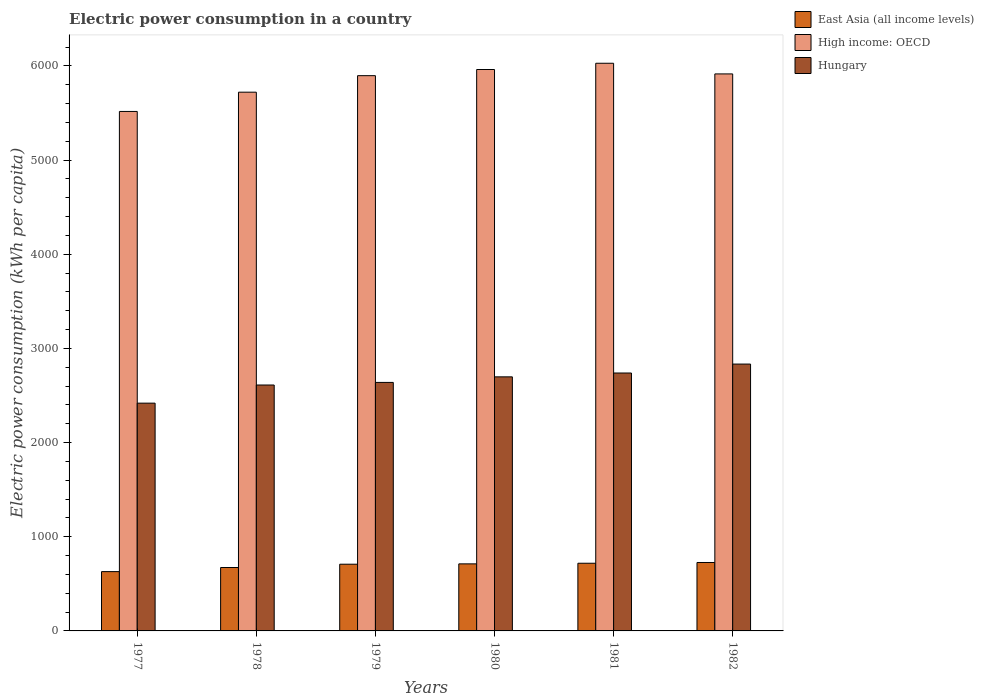How many different coloured bars are there?
Provide a succinct answer. 3. How many groups of bars are there?
Offer a very short reply. 6. Are the number of bars per tick equal to the number of legend labels?
Your answer should be very brief. Yes. How many bars are there on the 5th tick from the left?
Offer a terse response. 3. How many bars are there on the 3rd tick from the right?
Your response must be concise. 3. What is the label of the 3rd group of bars from the left?
Offer a very short reply. 1979. What is the electric power consumption in in East Asia (all income levels) in 1982?
Make the answer very short. 726.64. Across all years, what is the maximum electric power consumption in in High income: OECD?
Keep it short and to the point. 6027.52. Across all years, what is the minimum electric power consumption in in Hungary?
Make the answer very short. 2418.57. In which year was the electric power consumption in in East Asia (all income levels) maximum?
Provide a succinct answer. 1982. In which year was the electric power consumption in in East Asia (all income levels) minimum?
Offer a very short reply. 1977. What is the total electric power consumption in in Hungary in the graph?
Ensure brevity in your answer.  1.59e+04. What is the difference between the electric power consumption in in High income: OECD in 1981 and that in 1982?
Your answer should be compact. 113.2. What is the difference between the electric power consumption in in East Asia (all income levels) in 1977 and the electric power consumption in in High income: OECD in 1982?
Provide a succinct answer. -5284.6. What is the average electric power consumption in in East Asia (all income levels) per year?
Offer a very short reply. 694.78. In the year 1978, what is the difference between the electric power consumption in in East Asia (all income levels) and electric power consumption in in Hungary?
Make the answer very short. -1937.78. What is the ratio of the electric power consumption in in East Asia (all income levels) in 1978 to that in 1982?
Provide a succinct answer. 0.93. Is the electric power consumption in in East Asia (all income levels) in 1978 less than that in 1980?
Offer a very short reply. Yes. Is the difference between the electric power consumption in in East Asia (all income levels) in 1981 and 1982 greater than the difference between the electric power consumption in in Hungary in 1981 and 1982?
Your response must be concise. Yes. What is the difference between the highest and the second highest electric power consumption in in High income: OECD?
Give a very brief answer. 66.38. What is the difference between the highest and the lowest electric power consumption in in Hungary?
Provide a succinct answer. 414.92. What does the 1st bar from the left in 1982 represents?
Offer a terse response. East Asia (all income levels). What does the 3rd bar from the right in 1982 represents?
Make the answer very short. East Asia (all income levels). Are all the bars in the graph horizontal?
Provide a succinct answer. No. How many legend labels are there?
Offer a terse response. 3. What is the title of the graph?
Your answer should be very brief. Electric power consumption in a country. Does "Peru" appear as one of the legend labels in the graph?
Give a very brief answer. No. What is the label or title of the Y-axis?
Offer a very short reply. Electric power consumption (kWh per capita). What is the Electric power consumption (kWh per capita) in East Asia (all income levels) in 1977?
Your response must be concise. 629.72. What is the Electric power consumption (kWh per capita) of High income: OECD in 1977?
Provide a short and direct response. 5515.92. What is the Electric power consumption (kWh per capita) of Hungary in 1977?
Offer a terse response. 2418.57. What is the Electric power consumption (kWh per capita) of East Asia (all income levels) in 1978?
Keep it short and to the point. 673.4. What is the Electric power consumption (kWh per capita) of High income: OECD in 1978?
Make the answer very short. 5720.35. What is the Electric power consumption (kWh per capita) of Hungary in 1978?
Provide a succinct answer. 2611.18. What is the Electric power consumption (kWh per capita) of East Asia (all income levels) in 1979?
Provide a succinct answer. 708.39. What is the Electric power consumption (kWh per capita) in High income: OECD in 1979?
Your response must be concise. 5895.81. What is the Electric power consumption (kWh per capita) in Hungary in 1979?
Offer a terse response. 2638.7. What is the Electric power consumption (kWh per capita) of East Asia (all income levels) in 1980?
Keep it short and to the point. 711.96. What is the Electric power consumption (kWh per capita) of High income: OECD in 1980?
Keep it short and to the point. 5961.14. What is the Electric power consumption (kWh per capita) in Hungary in 1980?
Your response must be concise. 2697.76. What is the Electric power consumption (kWh per capita) of East Asia (all income levels) in 1981?
Keep it short and to the point. 718.57. What is the Electric power consumption (kWh per capita) in High income: OECD in 1981?
Your response must be concise. 6027.52. What is the Electric power consumption (kWh per capita) in Hungary in 1981?
Keep it short and to the point. 2738.56. What is the Electric power consumption (kWh per capita) in East Asia (all income levels) in 1982?
Your answer should be very brief. 726.64. What is the Electric power consumption (kWh per capita) in High income: OECD in 1982?
Your answer should be compact. 5914.32. What is the Electric power consumption (kWh per capita) in Hungary in 1982?
Your answer should be very brief. 2833.49. Across all years, what is the maximum Electric power consumption (kWh per capita) of East Asia (all income levels)?
Keep it short and to the point. 726.64. Across all years, what is the maximum Electric power consumption (kWh per capita) in High income: OECD?
Your answer should be very brief. 6027.52. Across all years, what is the maximum Electric power consumption (kWh per capita) in Hungary?
Ensure brevity in your answer.  2833.49. Across all years, what is the minimum Electric power consumption (kWh per capita) of East Asia (all income levels)?
Your response must be concise. 629.72. Across all years, what is the minimum Electric power consumption (kWh per capita) in High income: OECD?
Your answer should be compact. 5515.92. Across all years, what is the minimum Electric power consumption (kWh per capita) of Hungary?
Keep it short and to the point. 2418.57. What is the total Electric power consumption (kWh per capita) in East Asia (all income levels) in the graph?
Keep it short and to the point. 4168.68. What is the total Electric power consumption (kWh per capita) of High income: OECD in the graph?
Your response must be concise. 3.50e+04. What is the total Electric power consumption (kWh per capita) of Hungary in the graph?
Provide a succinct answer. 1.59e+04. What is the difference between the Electric power consumption (kWh per capita) of East Asia (all income levels) in 1977 and that in 1978?
Your answer should be very brief. -43.68. What is the difference between the Electric power consumption (kWh per capita) of High income: OECD in 1977 and that in 1978?
Keep it short and to the point. -204.43. What is the difference between the Electric power consumption (kWh per capita) of Hungary in 1977 and that in 1978?
Ensure brevity in your answer.  -192.61. What is the difference between the Electric power consumption (kWh per capita) in East Asia (all income levels) in 1977 and that in 1979?
Keep it short and to the point. -78.67. What is the difference between the Electric power consumption (kWh per capita) of High income: OECD in 1977 and that in 1979?
Your answer should be very brief. -379.89. What is the difference between the Electric power consumption (kWh per capita) of Hungary in 1977 and that in 1979?
Offer a very short reply. -220.13. What is the difference between the Electric power consumption (kWh per capita) of East Asia (all income levels) in 1977 and that in 1980?
Your answer should be very brief. -82.23. What is the difference between the Electric power consumption (kWh per capita) of High income: OECD in 1977 and that in 1980?
Offer a terse response. -445.22. What is the difference between the Electric power consumption (kWh per capita) in Hungary in 1977 and that in 1980?
Your response must be concise. -279.19. What is the difference between the Electric power consumption (kWh per capita) of East Asia (all income levels) in 1977 and that in 1981?
Ensure brevity in your answer.  -88.85. What is the difference between the Electric power consumption (kWh per capita) in High income: OECD in 1977 and that in 1981?
Offer a very short reply. -511.6. What is the difference between the Electric power consumption (kWh per capita) of Hungary in 1977 and that in 1981?
Ensure brevity in your answer.  -319.99. What is the difference between the Electric power consumption (kWh per capita) of East Asia (all income levels) in 1977 and that in 1982?
Provide a succinct answer. -96.92. What is the difference between the Electric power consumption (kWh per capita) of High income: OECD in 1977 and that in 1982?
Offer a terse response. -398.4. What is the difference between the Electric power consumption (kWh per capita) of Hungary in 1977 and that in 1982?
Make the answer very short. -414.92. What is the difference between the Electric power consumption (kWh per capita) of East Asia (all income levels) in 1978 and that in 1979?
Your answer should be compact. -34.99. What is the difference between the Electric power consumption (kWh per capita) in High income: OECD in 1978 and that in 1979?
Ensure brevity in your answer.  -175.47. What is the difference between the Electric power consumption (kWh per capita) of Hungary in 1978 and that in 1979?
Make the answer very short. -27.52. What is the difference between the Electric power consumption (kWh per capita) of East Asia (all income levels) in 1978 and that in 1980?
Your answer should be compact. -38.56. What is the difference between the Electric power consumption (kWh per capita) in High income: OECD in 1978 and that in 1980?
Give a very brief answer. -240.79. What is the difference between the Electric power consumption (kWh per capita) in Hungary in 1978 and that in 1980?
Your response must be concise. -86.58. What is the difference between the Electric power consumption (kWh per capita) in East Asia (all income levels) in 1978 and that in 1981?
Provide a succinct answer. -45.17. What is the difference between the Electric power consumption (kWh per capita) of High income: OECD in 1978 and that in 1981?
Ensure brevity in your answer.  -307.17. What is the difference between the Electric power consumption (kWh per capita) in Hungary in 1978 and that in 1981?
Keep it short and to the point. -127.38. What is the difference between the Electric power consumption (kWh per capita) of East Asia (all income levels) in 1978 and that in 1982?
Keep it short and to the point. -53.24. What is the difference between the Electric power consumption (kWh per capita) of High income: OECD in 1978 and that in 1982?
Ensure brevity in your answer.  -193.98. What is the difference between the Electric power consumption (kWh per capita) of Hungary in 1978 and that in 1982?
Your answer should be compact. -222.31. What is the difference between the Electric power consumption (kWh per capita) of East Asia (all income levels) in 1979 and that in 1980?
Ensure brevity in your answer.  -3.56. What is the difference between the Electric power consumption (kWh per capita) of High income: OECD in 1979 and that in 1980?
Give a very brief answer. -65.33. What is the difference between the Electric power consumption (kWh per capita) of Hungary in 1979 and that in 1980?
Provide a short and direct response. -59.06. What is the difference between the Electric power consumption (kWh per capita) in East Asia (all income levels) in 1979 and that in 1981?
Your response must be concise. -10.18. What is the difference between the Electric power consumption (kWh per capita) in High income: OECD in 1979 and that in 1981?
Give a very brief answer. -131.71. What is the difference between the Electric power consumption (kWh per capita) of Hungary in 1979 and that in 1981?
Make the answer very short. -99.86. What is the difference between the Electric power consumption (kWh per capita) of East Asia (all income levels) in 1979 and that in 1982?
Offer a very short reply. -18.25. What is the difference between the Electric power consumption (kWh per capita) in High income: OECD in 1979 and that in 1982?
Give a very brief answer. -18.51. What is the difference between the Electric power consumption (kWh per capita) in Hungary in 1979 and that in 1982?
Your answer should be very brief. -194.79. What is the difference between the Electric power consumption (kWh per capita) in East Asia (all income levels) in 1980 and that in 1981?
Ensure brevity in your answer.  -6.62. What is the difference between the Electric power consumption (kWh per capita) of High income: OECD in 1980 and that in 1981?
Offer a very short reply. -66.38. What is the difference between the Electric power consumption (kWh per capita) of Hungary in 1980 and that in 1981?
Give a very brief answer. -40.8. What is the difference between the Electric power consumption (kWh per capita) of East Asia (all income levels) in 1980 and that in 1982?
Provide a short and direct response. -14.69. What is the difference between the Electric power consumption (kWh per capita) of High income: OECD in 1980 and that in 1982?
Offer a terse response. 46.82. What is the difference between the Electric power consumption (kWh per capita) in Hungary in 1980 and that in 1982?
Provide a short and direct response. -135.73. What is the difference between the Electric power consumption (kWh per capita) in East Asia (all income levels) in 1981 and that in 1982?
Provide a short and direct response. -8.07. What is the difference between the Electric power consumption (kWh per capita) in High income: OECD in 1981 and that in 1982?
Ensure brevity in your answer.  113.2. What is the difference between the Electric power consumption (kWh per capita) of Hungary in 1981 and that in 1982?
Keep it short and to the point. -94.93. What is the difference between the Electric power consumption (kWh per capita) of East Asia (all income levels) in 1977 and the Electric power consumption (kWh per capita) of High income: OECD in 1978?
Provide a succinct answer. -5090.62. What is the difference between the Electric power consumption (kWh per capita) of East Asia (all income levels) in 1977 and the Electric power consumption (kWh per capita) of Hungary in 1978?
Ensure brevity in your answer.  -1981.46. What is the difference between the Electric power consumption (kWh per capita) in High income: OECD in 1977 and the Electric power consumption (kWh per capita) in Hungary in 1978?
Provide a short and direct response. 2904.74. What is the difference between the Electric power consumption (kWh per capita) in East Asia (all income levels) in 1977 and the Electric power consumption (kWh per capita) in High income: OECD in 1979?
Offer a terse response. -5266.09. What is the difference between the Electric power consumption (kWh per capita) in East Asia (all income levels) in 1977 and the Electric power consumption (kWh per capita) in Hungary in 1979?
Offer a very short reply. -2008.97. What is the difference between the Electric power consumption (kWh per capita) in High income: OECD in 1977 and the Electric power consumption (kWh per capita) in Hungary in 1979?
Your response must be concise. 2877.22. What is the difference between the Electric power consumption (kWh per capita) of East Asia (all income levels) in 1977 and the Electric power consumption (kWh per capita) of High income: OECD in 1980?
Make the answer very short. -5331.42. What is the difference between the Electric power consumption (kWh per capita) in East Asia (all income levels) in 1977 and the Electric power consumption (kWh per capita) in Hungary in 1980?
Provide a succinct answer. -2068.04. What is the difference between the Electric power consumption (kWh per capita) in High income: OECD in 1977 and the Electric power consumption (kWh per capita) in Hungary in 1980?
Give a very brief answer. 2818.16. What is the difference between the Electric power consumption (kWh per capita) of East Asia (all income levels) in 1977 and the Electric power consumption (kWh per capita) of High income: OECD in 1981?
Offer a very short reply. -5397.8. What is the difference between the Electric power consumption (kWh per capita) of East Asia (all income levels) in 1977 and the Electric power consumption (kWh per capita) of Hungary in 1981?
Provide a succinct answer. -2108.83. What is the difference between the Electric power consumption (kWh per capita) of High income: OECD in 1977 and the Electric power consumption (kWh per capita) of Hungary in 1981?
Ensure brevity in your answer.  2777.36. What is the difference between the Electric power consumption (kWh per capita) in East Asia (all income levels) in 1977 and the Electric power consumption (kWh per capita) in High income: OECD in 1982?
Your answer should be very brief. -5284.6. What is the difference between the Electric power consumption (kWh per capita) of East Asia (all income levels) in 1977 and the Electric power consumption (kWh per capita) of Hungary in 1982?
Provide a succinct answer. -2203.77. What is the difference between the Electric power consumption (kWh per capita) of High income: OECD in 1977 and the Electric power consumption (kWh per capita) of Hungary in 1982?
Offer a terse response. 2682.43. What is the difference between the Electric power consumption (kWh per capita) of East Asia (all income levels) in 1978 and the Electric power consumption (kWh per capita) of High income: OECD in 1979?
Provide a succinct answer. -5222.41. What is the difference between the Electric power consumption (kWh per capita) of East Asia (all income levels) in 1978 and the Electric power consumption (kWh per capita) of Hungary in 1979?
Make the answer very short. -1965.3. What is the difference between the Electric power consumption (kWh per capita) in High income: OECD in 1978 and the Electric power consumption (kWh per capita) in Hungary in 1979?
Your response must be concise. 3081.65. What is the difference between the Electric power consumption (kWh per capita) in East Asia (all income levels) in 1978 and the Electric power consumption (kWh per capita) in High income: OECD in 1980?
Your answer should be compact. -5287.74. What is the difference between the Electric power consumption (kWh per capita) in East Asia (all income levels) in 1978 and the Electric power consumption (kWh per capita) in Hungary in 1980?
Make the answer very short. -2024.36. What is the difference between the Electric power consumption (kWh per capita) in High income: OECD in 1978 and the Electric power consumption (kWh per capita) in Hungary in 1980?
Provide a short and direct response. 3022.59. What is the difference between the Electric power consumption (kWh per capita) in East Asia (all income levels) in 1978 and the Electric power consumption (kWh per capita) in High income: OECD in 1981?
Offer a terse response. -5354.12. What is the difference between the Electric power consumption (kWh per capita) in East Asia (all income levels) in 1978 and the Electric power consumption (kWh per capita) in Hungary in 1981?
Keep it short and to the point. -2065.16. What is the difference between the Electric power consumption (kWh per capita) of High income: OECD in 1978 and the Electric power consumption (kWh per capita) of Hungary in 1981?
Your response must be concise. 2981.79. What is the difference between the Electric power consumption (kWh per capita) of East Asia (all income levels) in 1978 and the Electric power consumption (kWh per capita) of High income: OECD in 1982?
Offer a very short reply. -5240.92. What is the difference between the Electric power consumption (kWh per capita) in East Asia (all income levels) in 1978 and the Electric power consumption (kWh per capita) in Hungary in 1982?
Your response must be concise. -2160.09. What is the difference between the Electric power consumption (kWh per capita) in High income: OECD in 1978 and the Electric power consumption (kWh per capita) in Hungary in 1982?
Ensure brevity in your answer.  2886.86. What is the difference between the Electric power consumption (kWh per capita) in East Asia (all income levels) in 1979 and the Electric power consumption (kWh per capita) in High income: OECD in 1980?
Offer a terse response. -5252.75. What is the difference between the Electric power consumption (kWh per capita) in East Asia (all income levels) in 1979 and the Electric power consumption (kWh per capita) in Hungary in 1980?
Provide a succinct answer. -1989.37. What is the difference between the Electric power consumption (kWh per capita) of High income: OECD in 1979 and the Electric power consumption (kWh per capita) of Hungary in 1980?
Ensure brevity in your answer.  3198.05. What is the difference between the Electric power consumption (kWh per capita) of East Asia (all income levels) in 1979 and the Electric power consumption (kWh per capita) of High income: OECD in 1981?
Your answer should be very brief. -5319.13. What is the difference between the Electric power consumption (kWh per capita) in East Asia (all income levels) in 1979 and the Electric power consumption (kWh per capita) in Hungary in 1981?
Offer a very short reply. -2030.17. What is the difference between the Electric power consumption (kWh per capita) of High income: OECD in 1979 and the Electric power consumption (kWh per capita) of Hungary in 1981?
Provide a short and direct response. 3157.25. What is the difference between the Electric power consumption (kWh per capita) of East Asia (all income levels) in 1979 and the Electric power consumption (kWh per capita) of High income: OECD in 1982?
Your answer should be very brief. -5205.93. What is the difference between the Electric power consumption (kWh per capita) in East Asia (all income levels) in 1979 and the Electric power consumption (kWh per capita) in Hungary in 1982?
Ensure brevity in your answer.  -2125.1. What is the difference between the Electric power consumption (kWh per capita) of High income: OECD in 1979 and the Electric power consumption (kWh per capita) of Hungary in 1982?
Provide a succinct answer. 3062.32. What is the difference between the Electric power consumption (kWh per capita) of East Asia (all income levels) in 1980 and the Electric power consumption (kWh per capita) of High income: OECD in 1981?
Offer a terse response. -5315.56. What is the difference between the Electric power consumption (kWh per capita) in East Asia (all income levels) in 1980 and the Electric power consumption (kWh per capita) in Hungary in 1981?
Keep it short and to the point. -2026.6. What is the difference between the Electric power consumption (kWh per capita) in High income: OECD in 1980 and the Electric power consumption (kWh per capita) in Hungary in 1981?
Provide a short and direct response. 3222.58. What is the difference between the Electric power consumption (kWh per capita) in East Asia (all income levels) in 1980 and the Electric power consumption (kWh per capita) in High income: OECD in 1982?
Provide a succinct answer. -5202.37. What is the difference between the Electric power consumption (kWh per capita) in East Asia (all income levels) in 1980 and the Electric power consumption (kWh per capita) in Hungary in 1982?
Make the answer very short. -2121.53. What is the difference between the Electric power consumption (kWh per capita) of High income: OECD in 1980 and the Electric power consumption (kWh per capita) of Hungary in 1982?
Give a very brief answer. 3127.65. What is the difference between the Electric power consumption (kWh per capita) in East Asia (all income levels) in 1981 and the Electric power consumption (kWh per capita) in High income: OECD in 1982?
Your answer should be compact. -5195.75. What is the difference between the Electric power consumption (kWh per capita) in East Asia (all income levels) in 1981 and the Electric power consumption (kWh per capita) in Hungary in 1982?
Provide a succinct answer. -2114.91. What is the difference between the Electric power consumption (kWh per capita) of High income: OECD in 1981 and the Electric power consumption (kWh per capita) of Hungary in 1982?
Give a very brief answer. 3194.03. What is the average Electric power consumption (kWh per capita) in East Asia (all income levels) per year?
Give a very brief answer. 694.78. What is the average Electric power consumption (kWh per capita) in High income: OECD per year?
Offer a terse response. 5839.18. What is the average Electric power consumption (kWh per capita) of Hungary per year?
Make the answer very short. 2656.37. In the year 1977, what is the difference between the Electric power consumption (kWh per capita) of East Asia (all income levels) and Electric power consumption (kWh per capita) of High income: OECD?
Ensure brevity in your answer.  -4886.2. In the year 1977, what is the difference between the Electric power consumption (kWh per capita) in East Asia (all income levels) and Electric power consumption (kWh per capita) in Hungary?
Make the answer very short. -1788.85. In the year 1977, what is the difference between the Electric power consumption (kWh per capita) in High income: OECD and Electric power consumption (kWh per capita) in Hungary?
Provide a succinct answer. 3097.35. In the year 1978, what is the difference between the Electric power consumption (kWh per capita) in East Asia (all income levels) and Electric power consumption (kWh per capita) in High income: OECD?
Your answer should be compact. -5046.95. In the year 1978, what is the difference between the Electric power consumption (kWh per capita) of East Asia (all income levels) and Electric power consumption (kWh per capita) of Hungary?
Make the answer very short. -1937.78. In the year 1978, what is the difference between the Electric power consumption (kWh per capita) of High income: OECD and Electric power consumption (kWh per capita) of Hungary?
Your answer should be very brief. 3109.17. In the year 1979, what is the difference between the Electric power consumption (kWh per capita) of East Asia (all income levels) and Electric power consumption (kWh per capita) of High income: OECD?
Your answer should be very brief. -5187.42. In the year 1979, what is the difference between the Electric power consumption (kWh per capita) of East Asia (all income levels) and Electric power consumption (kWh per capita) of Hungary?
Your answer should be compact. -1930.3. In the year 1979, what is the difference between the Electric power consumption (kWh per capita) in High income: OECD and Electric power consumption (kWh per capita) in Hungary?
Provide a short and direct response. 3257.12. In the year 1980, what is the difference between the Electric power consumption (kWh per capita) of East Asia (all income levels) and Electric power consumption (kWh per capita) of High income: OECD?
Give a very brief answer. -5249.18. In the year 1980, what is the difference between the Electric power consumption (kWh per capita) of East Asia (all income levels) and Electric power consumption (kWh per capita) of Hungary?
Make the answer very short. -1985.8. In the year 1980, what is the difference between the Electric power consumption (kWh per capita) in High income: OECD and Electric power consumption (kWh per capita) in Hungary?
Your response must be concise. 3263.38. In the year 1981, what is the difference between the Electric power consumption (kWh per capita) of East Asia (all income levels) and Electric power consumption (kWh per capita) of High income: OECD?
Your answer should be very brief. -5308.95. In the year 1981, what is the difference between the Electric power consumption (kWh per capita) of East Asia (all income levels) and Electric power consumption (kWh per capita) of Hungary?
Provide a succinct answer. -2019.98. In the year 1981, what is the difference between the Electric power consumption (kWh per capita) in High income: OECD and Electric power consumption (kWh per capita) in Hungary?
Keep it short and to the point. 3288.96. In the year 1982, what is the difference between the Electric power consumption (kWh per capita) of East Asia (all income levels) and Electric power consumption (kWh per capita) of High income: OECD?
Your answer should be compact. -5187.68. In the year 1982, what is the difference between the Electric power consumption (kWh per capita) of East Asia (all income levels) and Electric power consumption (kWh per capita) of Hungary?
Offer a very short reply. -2106.84. In the year 1982, what is the difference between the Electric power consumption (kWh per capita) of High income: OECD and Electric power consumption (kWh per capita) of Hungary?
Give a very brief answer. 3080.84. What is the ratio of the Electric power consumption (kWh per capita) in East Asia (all income levels) in 1977 to that in 1978?
Make the answer very short. 0.94. What is the ratio of the Electric power consumption (kWh per capita) of High income: OECD in 1977 to that in 1978?
Your response must be concise. 0.96. What is the ratio of the Electric power consumption (kWh per capita) in Hungary in 1977 to that in 1978?
Offer a terse response. 0.93. What is the ratio of the Electric power consumption (kWh per capita) of High income: OECD in 1977 to that in 1979?
Make the answer very short. 0.94. What is the ratio of the Electric power consumption (kWh per capita) of Hungary in 1977 to that in 1979?
Your response must be concise. 0.92. What is the ratio of the Electric power consumption (kWh per capita) of East Asia (all income levels) in 1977 to that in 1980?
Keep it short and to the point. 0.88. What is the ratio of the Electric power consumption (kWh per capita) of High income: OECD in 1977 to that in 1980?
Your answer should be compact. 0.93. What is the ratio of the Electric power consumption (kWh per capita) of Hungary in 1977 to that in 1980?
Keep it short and to the point. 0.9. What is the ratio of the Electric power consumption (kWh per capita) of East Asia (all income levels) in 1977 to that in 1981?
Your answer should be compact. 0.88. What is the ratio of the Electric power consumption (kWh per capita) of High income: OECD in 1977 to that in 1981?
Offer a terse response. 0.92. What is the ratio of the Electric power consumption (kWh per capita) in Hungary in 1977 to that in 1981?
Provide a succinct answer. 0.88. What is the ratio of the Electric power consumption (kWh per capita) in East Asia (all income levels) in 1977 to that in 1982?
Make the answer very short. 0.87. What is the ratio of the Electric power consumption (kWh per capita) in High income: OECD in 1977 to that in 1982?
Make the answer very short. 0.93. What is the ratio of the Electric power consumption (kWh per capita) of Hungary in 1977 to that in 1982?
Offer a terse response. 0.85. What is the ratio of the Electric power consumption (kWh per capita) in East Asia (all income levels) in 1978 to that in 1979?
Your answer should be very brief. 0.95. What is the ratio of the Electric power consumption (kWh per capita) of High income: OECD in 1978 to that in 1979?
Give a very brief answer. 0.97. What is the ratio of the Electric power consumption (kWh per capita) in Hungary in 1978 to that in 1979?
Ensure brevity in your answer.  0.99. What is the ratio of the Electric power consumption (kWh per capita) in East Asia (all income levels) in 1978 to that in 1980?
Keep it short and to the point. 0.95. What is the ratio of the Electric power consumption (kWh per capita) of High income: OECD in 1978 to that in 1980?
Offer a terse response. 0.96. What is the ratio of the Electric power consumption (kWh per capita) in Hungary in 1978 to that in 1980?
Provide a short and direct response. 0.97. What is the ratio of the Electric power consumption (kWh per capita) in East Asia (all income levels) in 1978 to that in 1981?
Your answer should be very brief. 0.94. What is the ratio of the Electric power consumption (kWh per capita) in High income: OECD in 1978 to that in 1981?
Offer a terse response. 0.95. What is the ratio of the Electric power consumption (kWh per capita) of Hungary in 1978 to that in 1981?
Your response must be concise. 0.95. What is the ratio of the Electric power consumption (kWh per capita) of East Asia (all income levels) in 1978 to that in 1982?
Provide a short and direct response. 0.93. What is the ratio of the Electric power consumption (kWh per capita) in High income: OECD in 1978 to that in 1982?
Provide a short and direct response. 0.97. What is the ratio of the Electric power consumption (kWh per capita) in Hungary in 1978 to that in 1982?
Ensure brevity in your answer.  0.92. What is the ratio of the Electric power consumption (kWh per capita) in High income: OECD in 1979 to that in 1980?
Offer a terse response. 0.99. What is the ratio of the Electric power consumption (kWh per capita) in Hungary in 1979 to that in 1980?
Keep it short and to the point. 0.98. What is the ratio of the Electric power consumption (kWh per capita) of East Asia (all income levels) in 1979 to that in 1981?
Make the answer very short. 0.99. What is the ratio of the Electric power consumption (kWh per capita) in High income: OECD in 1979 to that in 1981?
Offer a very short reply. 0.98. What is the ratio of the Electric power consumption (kWh per capita) of Hungary in 1979 to that in 1981?
Your answer should be compact. 0.96. What is the ratio of the Electric power consumption (kWh per capita) of East Asia (all income levels) in 1979 to that in 1982?
Ensure brevity in your answer.  0.97. What is the ratio of the Electric power consumption (kWh per capita) in High income: OECD in 1979 to that in 1982?
Keep it short and to the point. 1. What is the ratio of the Electric power consumption (kWh per capita) in Hungary in 1979 to that in 1982?
Offer a terse response. 0.93. What is the ratio of the Electric power consumption (kWh per capita) in East Asia (all income levels) in 1980 to that in 1981?
Offer a terse response. 0.99. What is the ratio of the Electric power consumption (kWh per capita) in High income: OECD in 1980 to that in 1981?
Your response must be concise. 0.99. What is the ratio of the Electric power consumption (kWh per capita) of Hungary in 1980 to that in 1981?
Your answer should be compact. 0.99. What is the ratio of the Electric power consumption (kWh per capita) of East Asia (all income levels) in 1980 to that in 1982?
Give a very brief answer. 0.98. What is the ratio of the Electric power consumption (kWh per capita) of High income: OECD in 1980 to that in 1982?
Offer a very short reply. 1.01. What is the ratio of the Electric power consumption (kWh per capita) in Hungary in 1980 to that in 1982?
Give a very brief answer. 0.95. What is the ratio of the Electric power consumption (kWh per capita) in East Asia (all income levels) in 1981 to that in 1982?
Provide a short and direct response. 0.99. What is the ratio of the Electric power consumption (kWh per capita) of High income: OECD in 1981 to that in 1982?
Give a very brief answer. 1.02. What is the ratio of the Electric power consumption (kWh per capita) in Hungary in 1981 to that in 1982?
Ensure brevity in your answer.  0.97. What is the difference between the highest and the second highest Electric power consumption (kWh per capita) of East Asia (all income levels)?
Give a very brief answer. 8.07. What is the difference between the highest and the second highest Electric power consumption (kWh per capita) of High income: OECD?
Offer a terse response. 66.38. What is the difference between the highest and the second highest Electric power consumption (kWh per capita) in Hungary?
Your response must be concise. 94.93. What is the difference between the highest and the lowest Electric power consumption (kWh per capita) in East Asia (all income levels)?
Give a very brief answer. 96.92. What is the difference between the highest and the lowest Electric power consumption (kWh per capita) of High income: OECD?
Make the answer very short. 511.6. What is the difference between the highest and the lowest Electric power consumption (kWh per capita) in Hungary?
Give a very brief answer. 414.92. 